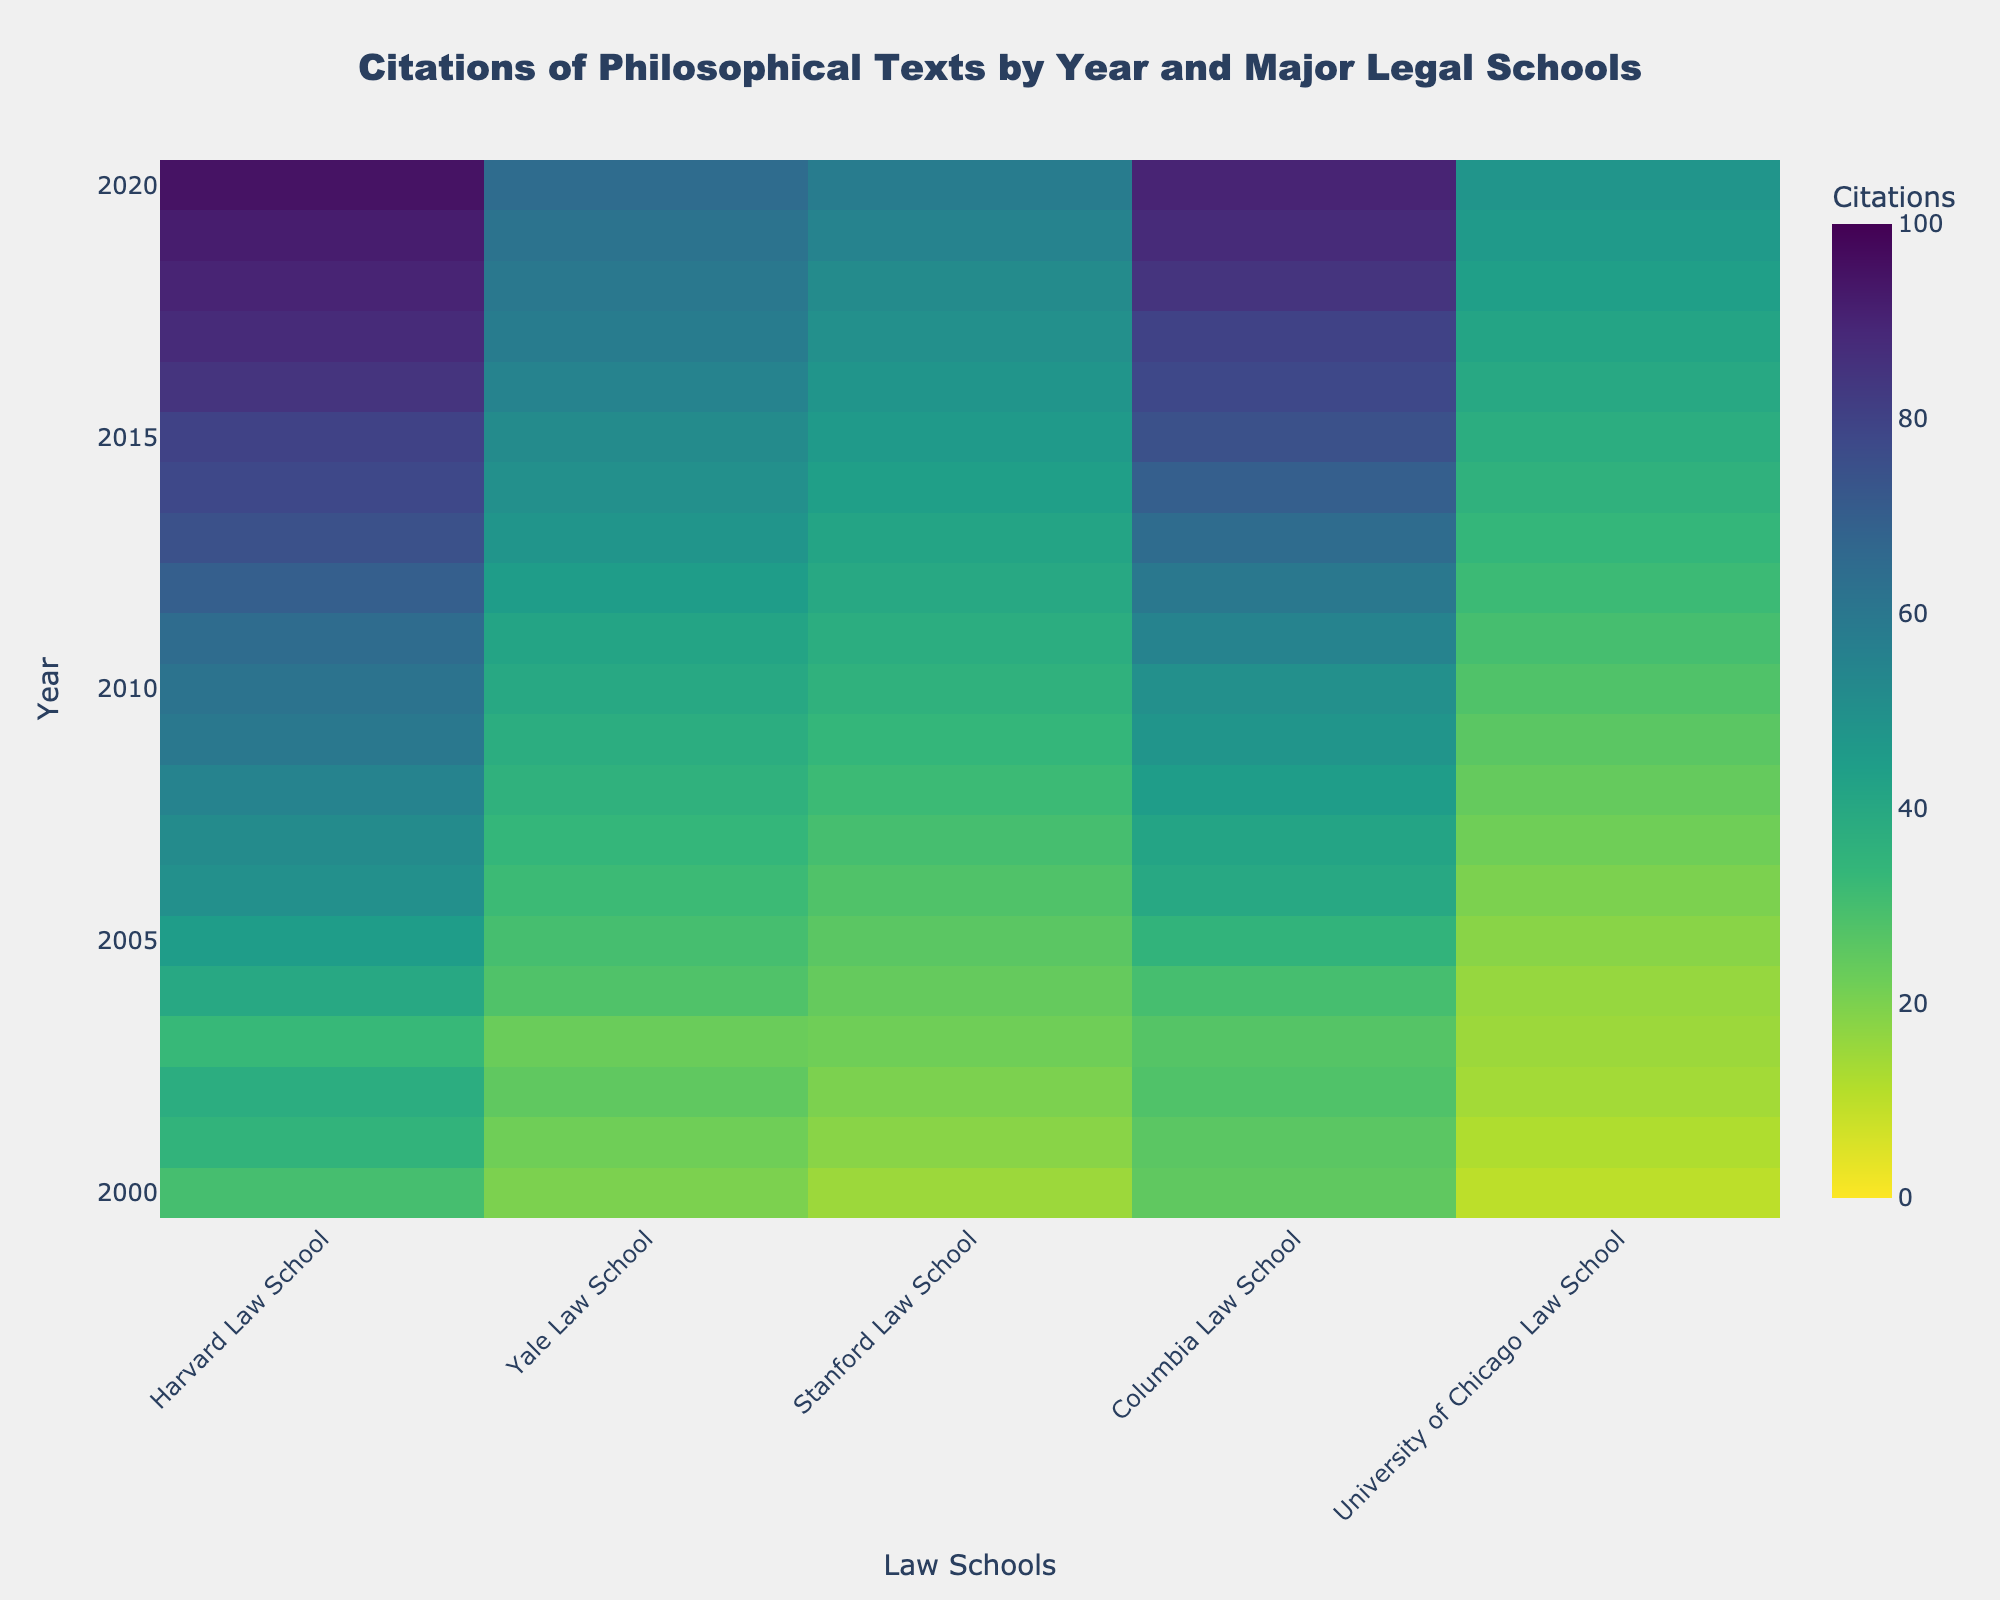What's the title of the heatmap? The title of the heatmap is at the top center of the figure. It reads "Citations of Philosophical Texts by Year and Major Legal Schools".
Answer: Citations of Philosophical Texts by Year and Major Legal Schools Which law school had the highest number of citations in 2019? To find this, look at the year 2019 on the y-axis and then scan across the schools on the x-axis. The color intensity (most likely the darker shade) indicates the highest value.
Answer: Harvard Law School Comparing Harvard and Yale Law Schools, which one had more citations in 2005? Locate 2005 on the y-axis and compare the values for Harvard and Yale. Harvard's number of citations is brighter (closer to 45) compared to Yale's (closer to 30).
Answer: Harvard Law School What is the trend of citations for Columbia Law School from 2000 to 2020? Trace the Columbia Law School's column from 2000 to 2020. Notice that the colors transition from lighter shades to darker shades, indicating an upward trend in the number of citations.
Answer: Upward trend How many total citations did Stanford Law School receive in 2003 and 2004 combined? Find the citations for Stanford Law School for the years 2003 and 2004. The values are 22 for 2003 and 24 for 2004, so sum them: 22 + 24 = 46.
Answer: 46 Which year showed the highest citations for the University of Chicago Law School? Look along the x-axis for the University of Chicago Law School and identify the year with the darkest shade. The darkest point appears in 2020.
Answer: 2020 Is there any year where all five schools had almost the same number of citations? Scan across the years and compare the consistency in colors across all five schools. While the values vary, the year 2003 shows relatively close citation counts among the schools (somewhere around 22-27).
Answer: 2003 By how much did the citations for Harvard Law School increase from 2001 to 2011? Locate 2001 and 2011 for Harvard Law School. The values are 35 for 2001 and 65 for 2011. Calculate the difference: 65 - 35 = 30.
Answer: 30 Which school demonstrated the most significant growth in citations from 2008 to 2018? Examine the colors for each school between 2008 and 2018. The most significant transition from a lighter to a darker shade occurs for Harvard Law School.
Answer: Harvard Law School How does the citations count for Yale Law School in 2012 compare to Stanford Law School in 2012? Trace 2012 on the y-axis for both Yale and Stanford. Yale has 45 citations while Stanford has 40. Yale has more citations in 2012.
Answer: Yale Law School 